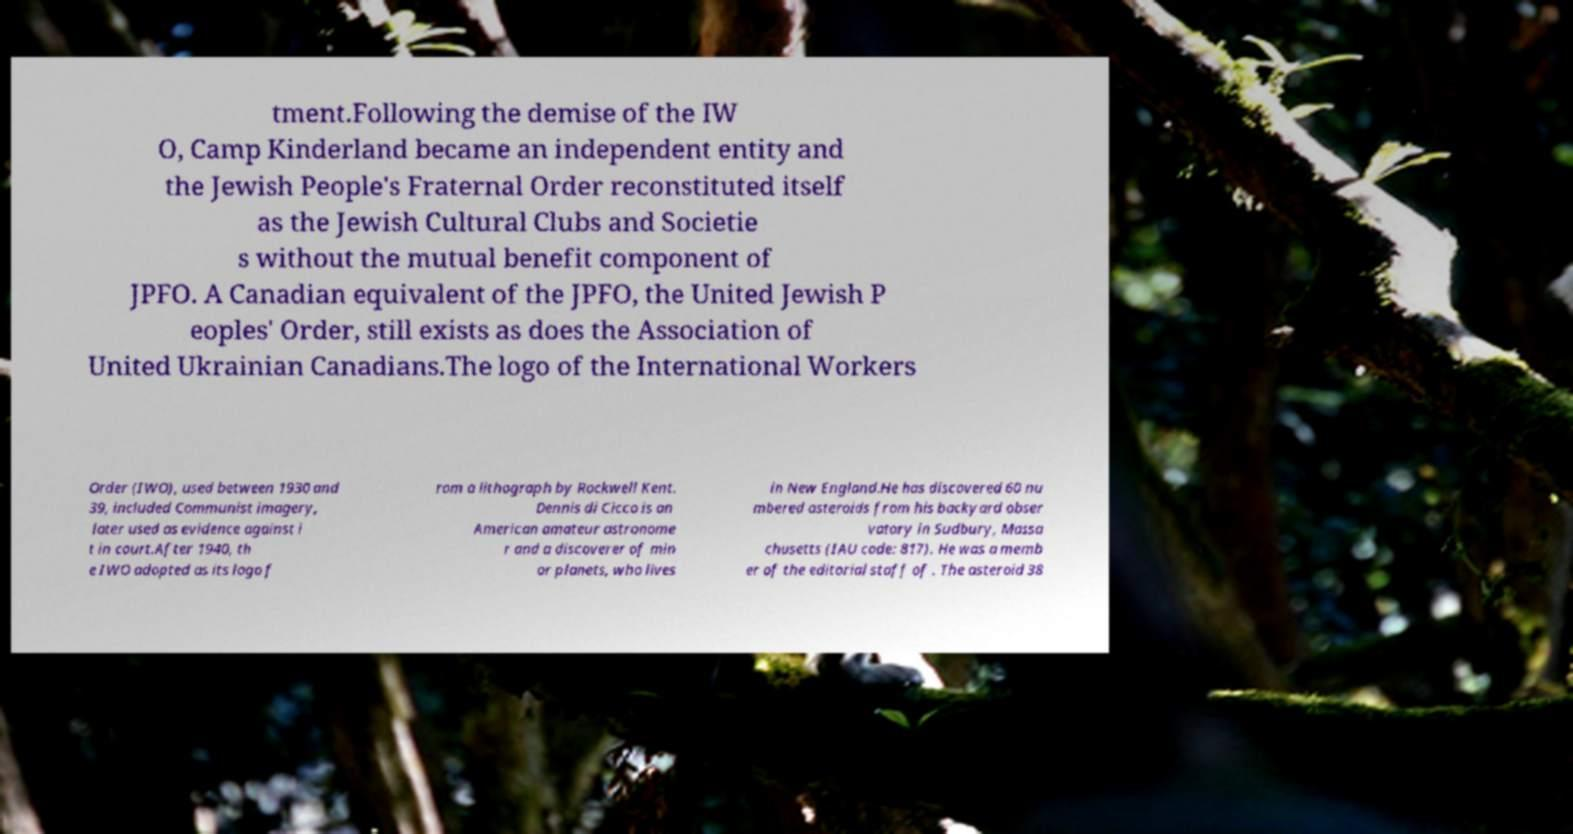Could you extract and type out the text from this image? tment.Following the demise of the IW O, Camp Kinderland became an independent entity and the Jewish People's Fraternal Order reconstituted itself as the Jewish Cultural Clubs and Societie s without the mutual benefit component of JPFO. A Canadian equivalent of the JPFO, the United Jewish P eoples' Order, still exists as does the Association of United Ukrainian Canadians.The logo of the International Workers Order (IWO), used between 1930 and 39, included Communist imagery, later used as evidence against i t in court.After 1940, th e IWO adopted as its logo f rom a lithograph by Rockwell Kent. Dennis di Cicco is an American amateur astronome r and a discoverer of min or planets, who lives in New England.He has discovered 60 nu mbered asteroids from his backyard obser vatory in Sudbury, Massa chusetts (IAU code: 817). He was a memb er of the editorial staff of . The asteroid 38 